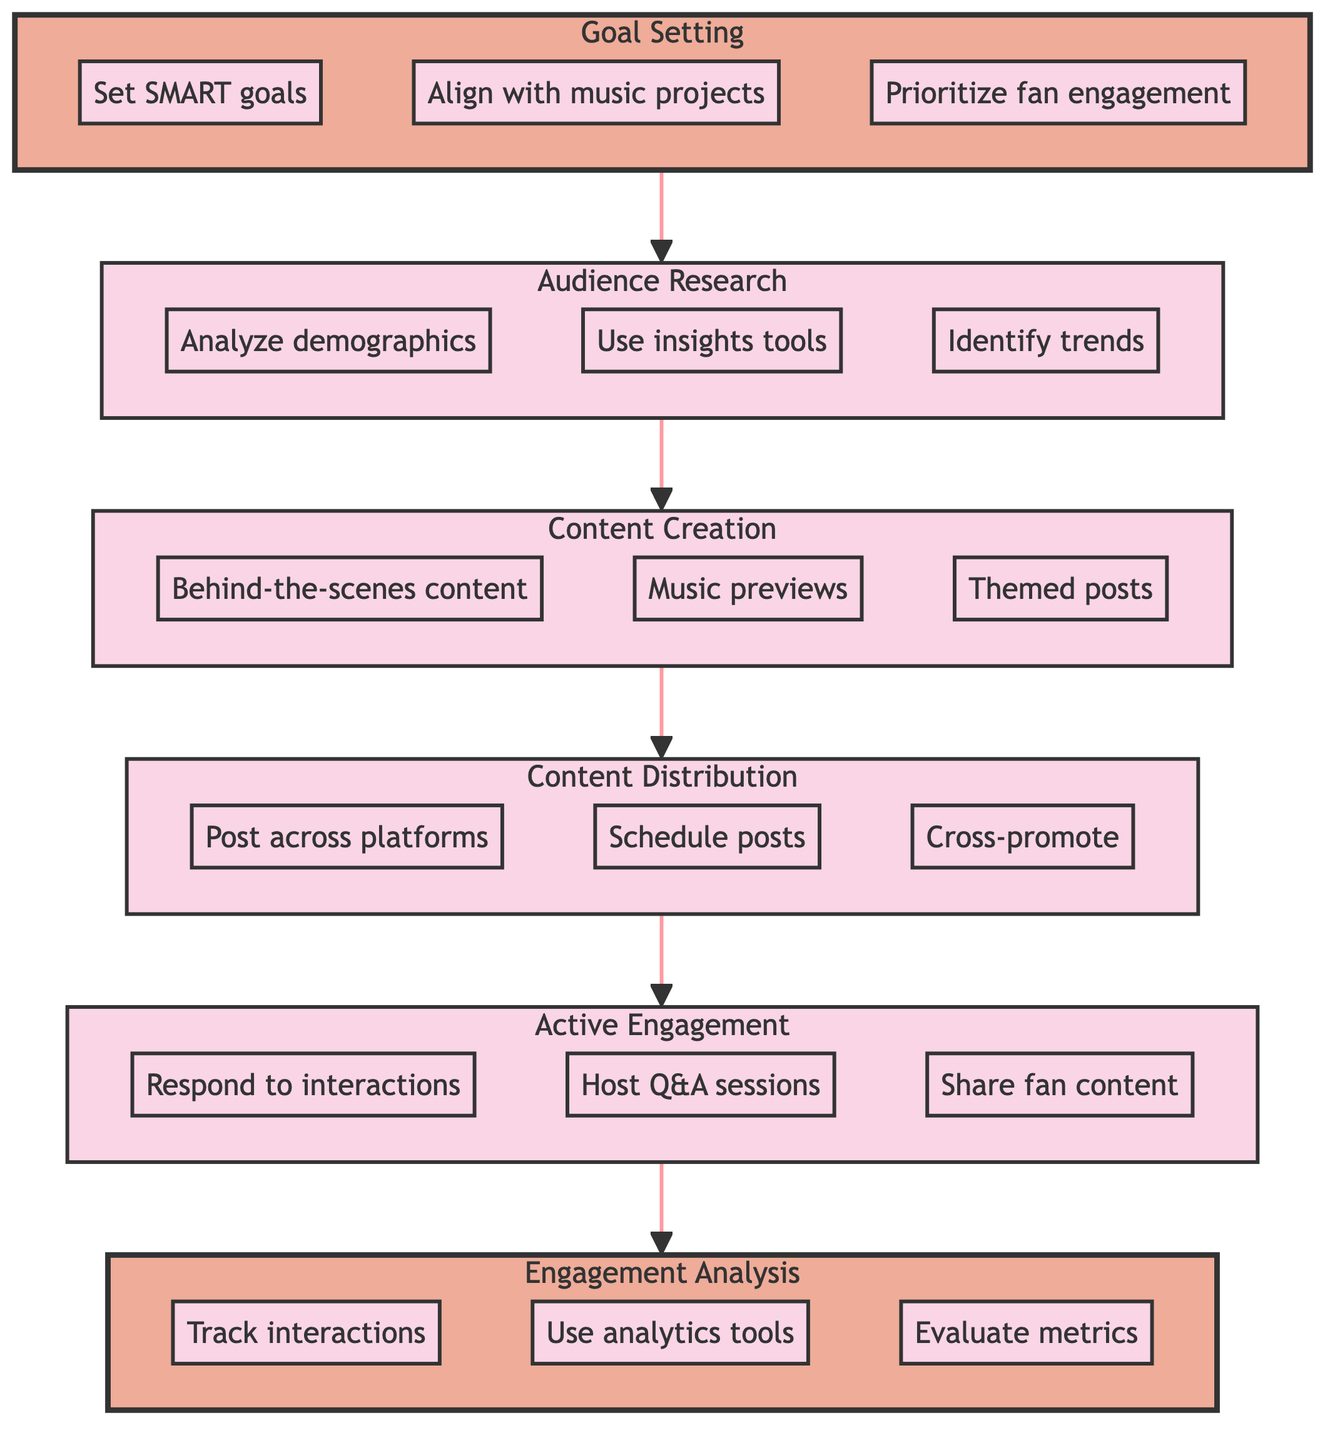What is the first step in the social media strategy? The diagram shows that the first step is "Goal Setting," which is displayed at the bottom of the flow chart.
Answer: Goal Setting How many total steps are in the process? The flow chart contains six distinct steps from bottom to top: Goal Setting, Audience Research, Content Creation, Content Distribution, Active Engagement, and Engagement Analysis.
Answer: Six Which step comes after Content Creation? According to the flow chart, "Content Distribution" directly follows "Content Creation," indicated by the arrow connecting them.
Answer: Content Distribution What are the actions listed under Engagement Analysis? The actions listed under "Engagement Analysis" include tracking interactions, using analytics tools, and evaluating metrics, as shown in the subgraph.
Answer: Track interactions, use analytics tools, evaluate metrics What is the relationship between Active Engagement and Engagement Analysis? Active Engagement is directly connected to Engagement Analysis, indicating that Active Engagement leads to Engagement Analysis in the workflow.
Answer: Active Engagement leads to Engagement Analysis What is the role of Audience Research in social media strategy? Audience Research comes right after Goal Setting and is crucial to understand follower demographics, interests, and trends, which feed into the content creation phase.
Answer: To understand follower demographics and trends What type of goals should be set according to the diagram? The diagram specifies that goals should be SMART, which stands for specific, measurable, achievable, relevant, and time-bound, reflecting an effective approach to goal setting.
Answer: SMART Which step involves responding to comments and messages? The diagram indicates that "Active Engagement" focuses on interacting with followers, which includes responding to comments and messages.
Answer: Active Engagement What allows the flow of the strategy and its steps? The arrows connecting the steps form a directed path that represents the process flow of developing the social media strategy from one step to the next.
Answer: Arrows between steps 